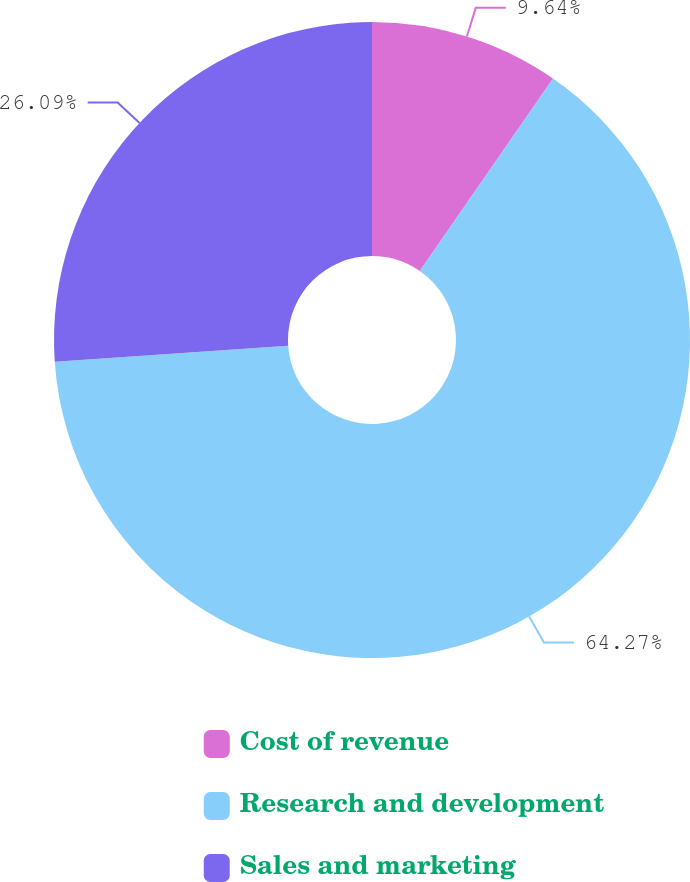Convert chart. <chart><loc_0><loc_0><loc_500><loc_500><pie_chart><fcel>Cost of revenue<fcel>Research and development<fcel>Sales and marketing<nl><fcel>9.64%<fcel>64.27%<fcel>26.09%<nl></chart> 